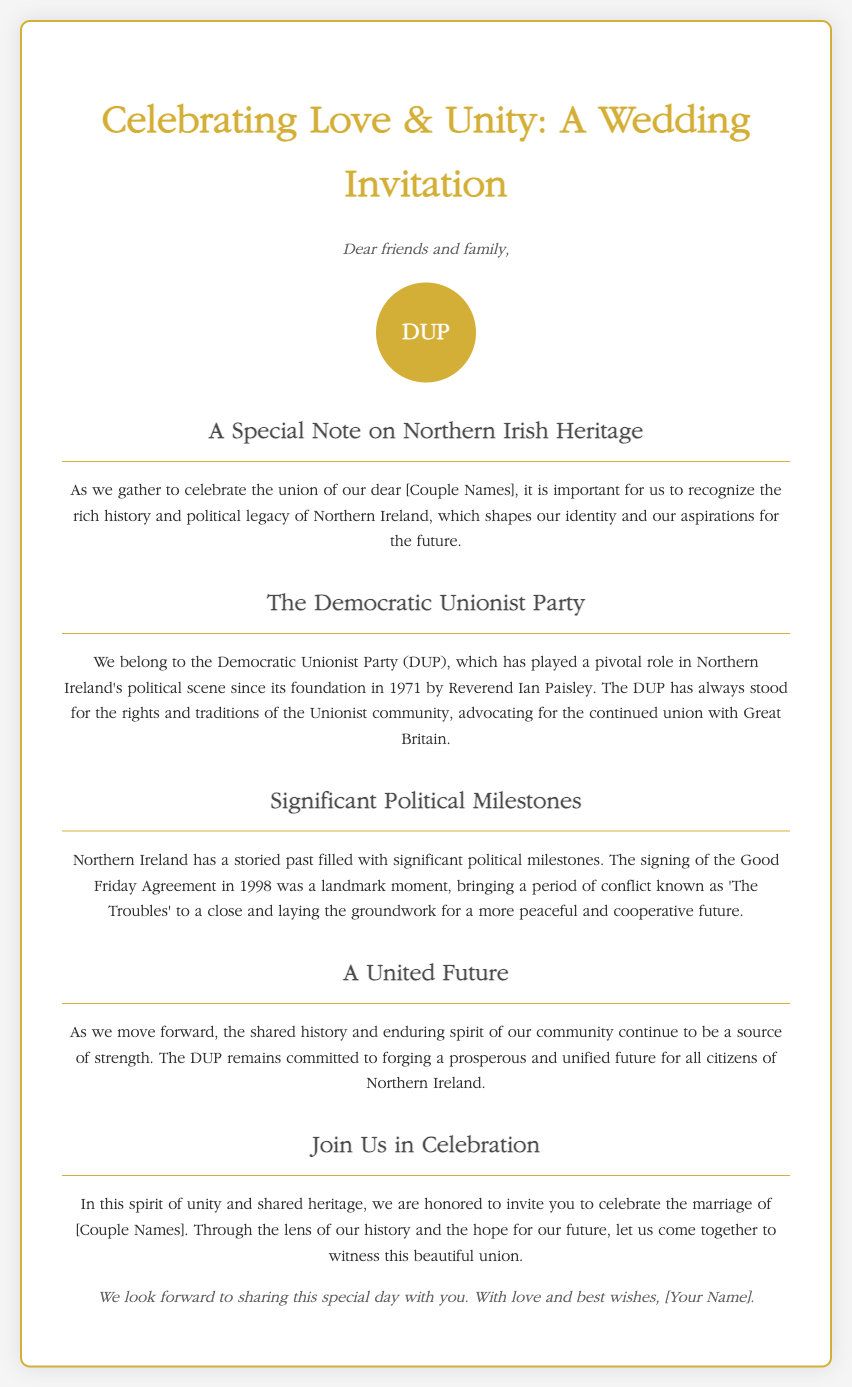What year was the Democratic Unionist Party founded? The founding year of the DUP is mentioned in the document.
Answer: 1971 Who founded the Democratic Unionist Party? The document states that Reverend Ian Paisley was the founder of the DUP.
Answer: Reverend Ian Paisley What significant agreement is mentioned in the document? The document specifically mentions a landmark agreement in Northern Irish history.
Answer: Good Friday Agreement What year was the Good Friday Agreement signed? The document provides a specific year for this important political event.
Answer: 1998 What is the primary political stance of the DUP? The document describes the stance of the DUP regarding the Unionist community.
Answer: Continued union with Great Britain What themes are emphasized in the wedding invitation? The document highlights key themes that resonate throughout the invitation.
Answer: Love & Unity What does the document invite guests to celebrate? The purpose of the invitation is clearly stated in the content.
Answer: Marriage of [Couple Names] What type of document is this? The overall type of the document is indicated within the title and content.
Answer: Wedding Invitation 